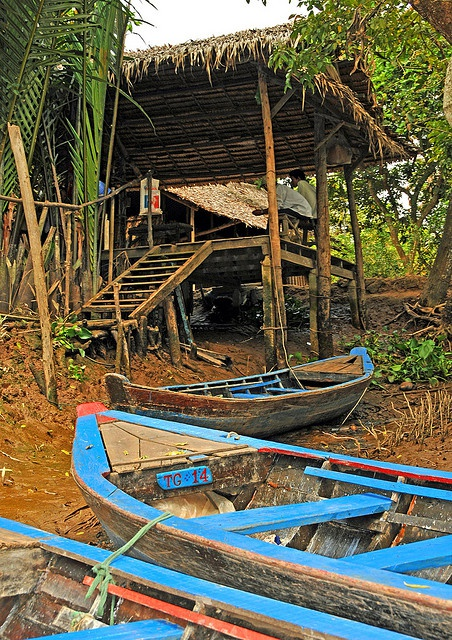Describe the objects in this image and their specific colors. I can see boat in black, gray, and lightblue tones, boat in black, tan, lightblue, and gray tones, boat in black, gray, and maroon tones, people in black, gray, and darkgray tones, and people in black, olive, and darkgreen tones in this image. 